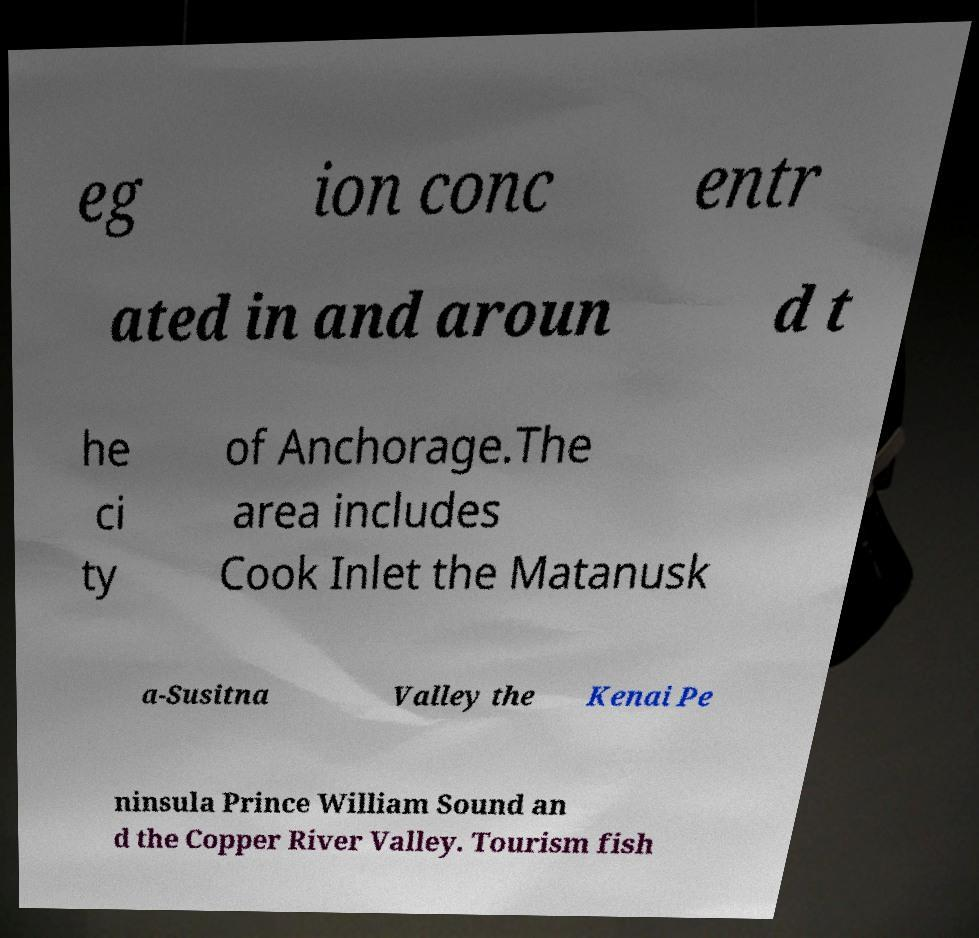Could you extract and type out the text from this image? eg ion conc entr ated in and aroun d t he ci ty of Anchorage.The area includes Cook Inlet the Matanusk a-Susitna Valley the Kenai Pe ninsula Prince William Sound an d the Copper River Valley. Tourism fish 